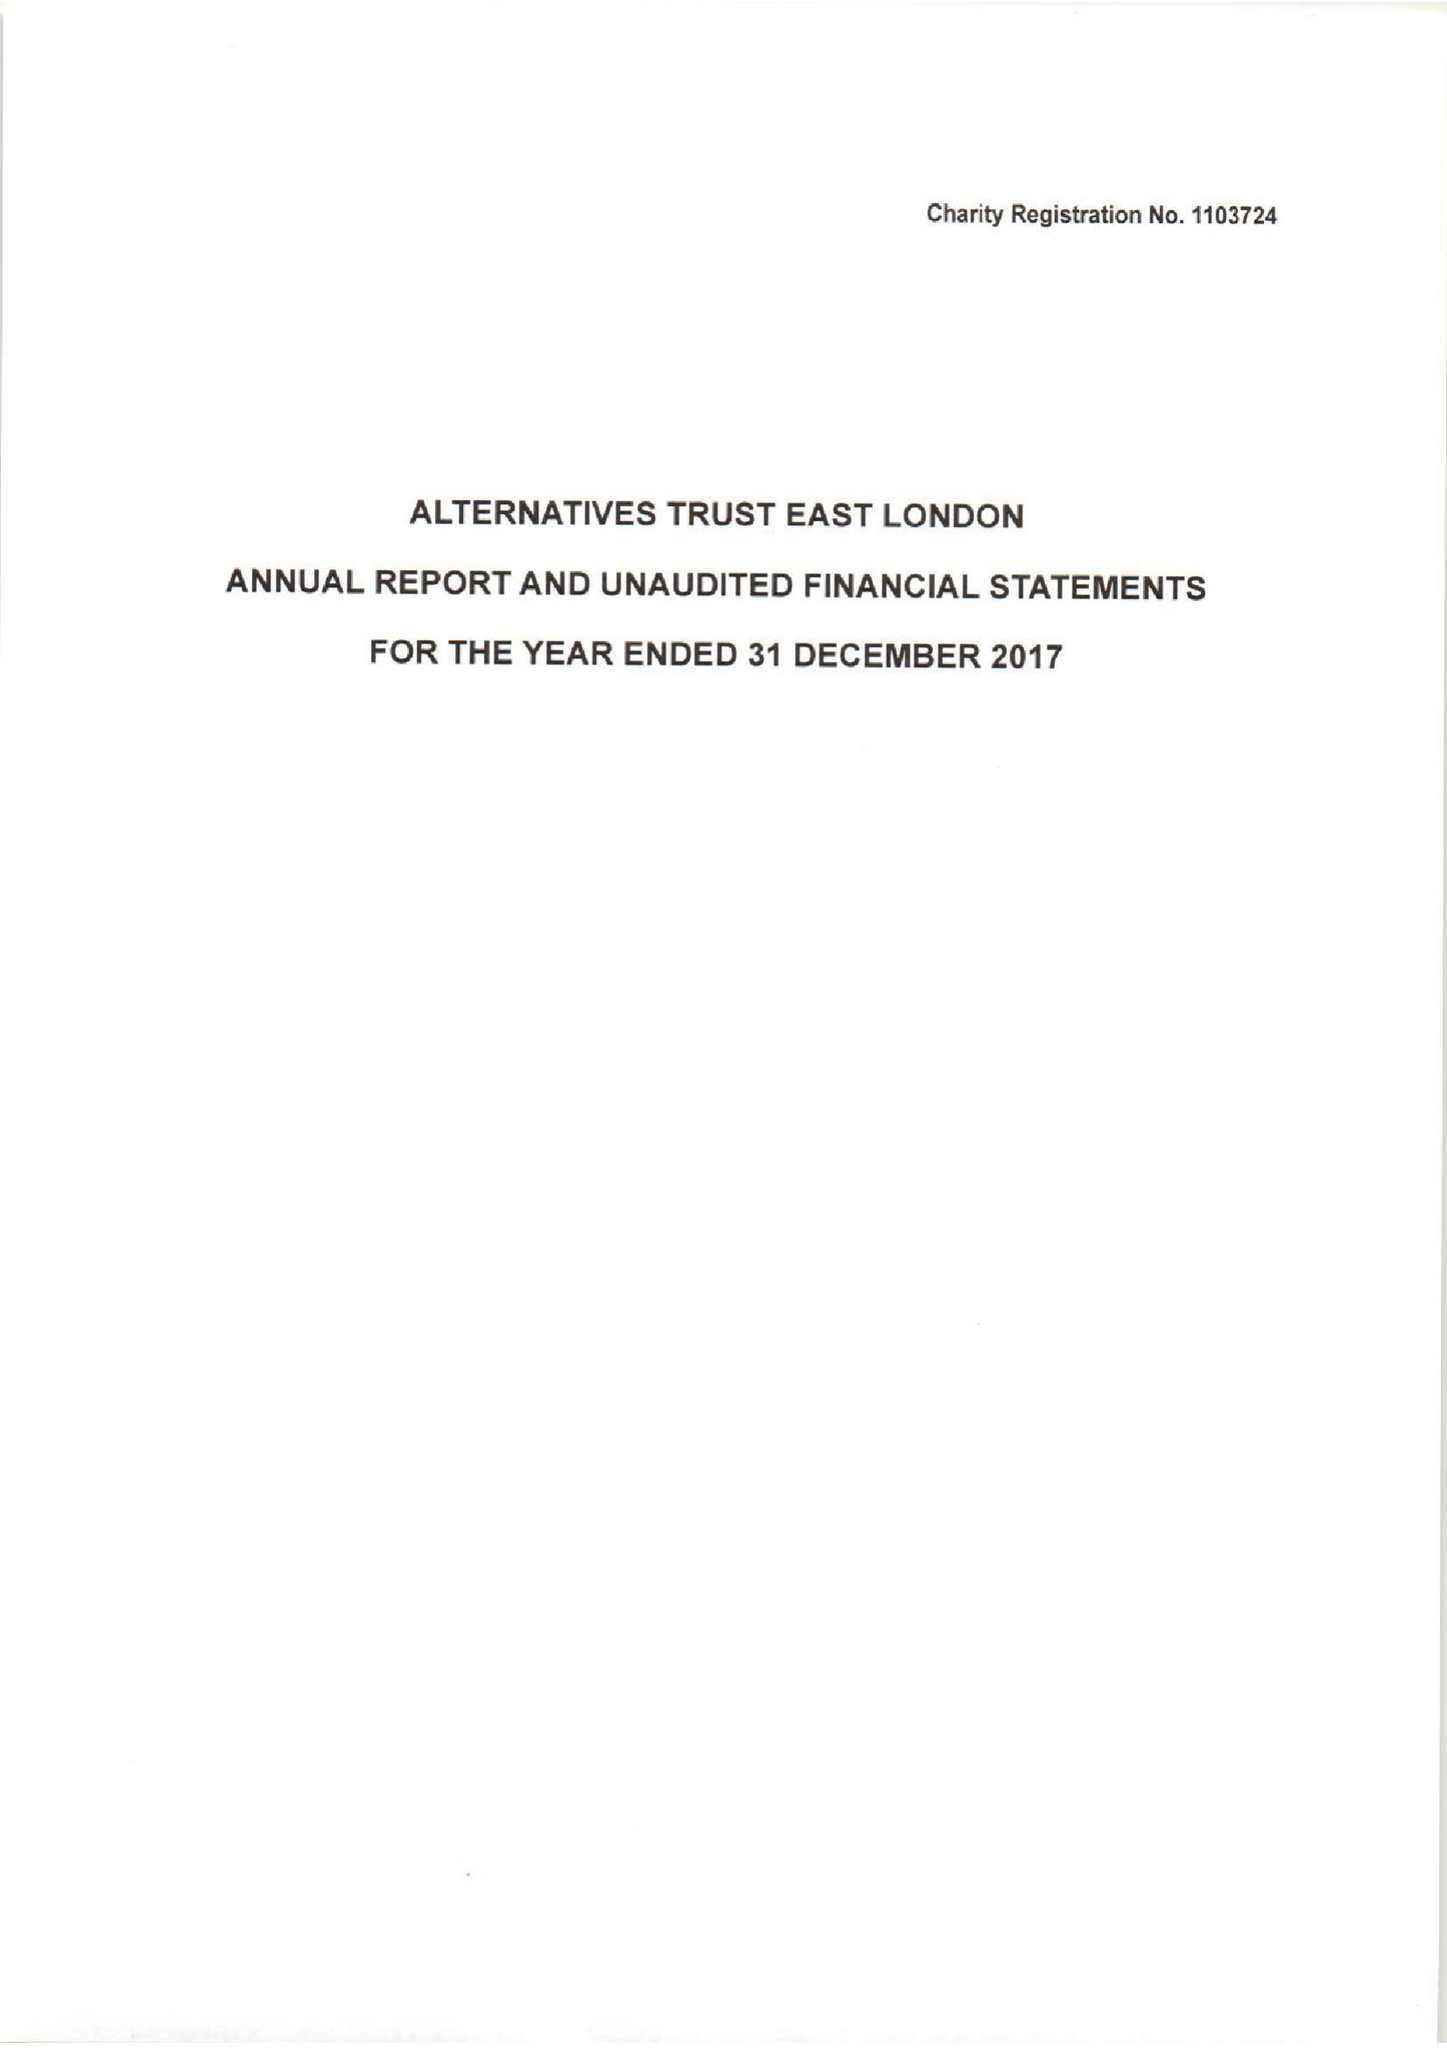What is the value for the address__street_line?
Answer the question using a single word or phrase. 63 ROWNTREE CLIFFORD CLOSE 